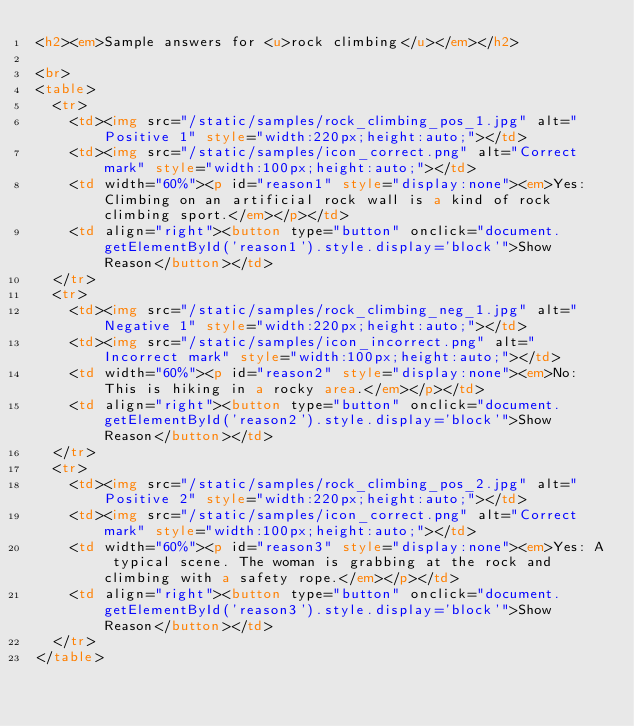Convert code to text. <code><loc_0><loc_0><loc_500><loc_500><_HTML_><h2><em>Sample answers for <u>rock climbing</u></em></h2>

<br>
<table>
	<tr>
		<td><img src="/static/samples/rock_climbing_pos_1.jpg" alt="Positive 1" style="width:220px;height:auto;"></td>
		<td><img src="/static/samples/icon_correct.png" alt="Correct mark" style="width:100px;height:auto;"></td>
		<td width="60%"><p id="reason1" style="display:none"><em>Yes: Climbing on an artificial rock wall is a kind of rock climbing sport.</em></p></td>
		<td align="right"><button type="button" onclick="document.getElementById('reason1').style.display='block'">Show Reason</button></td>
	</tr>
	<tr>
		<td><img src="/static/samples/rock_climbing_neg_1.jpg" alt="Negative 1" style="width:220px;height:auto;"></td>
		<td><img src="/static/samples/icon_incorrect.png" alt="Incorrect mark" style="width:100px;height:auto;"></td>
		<td width="60%"><p id="reason2" style="display:none"><em>No: This is hiking in a rocky area.</em></p></td>
		<td align="right"><button type="button" onclick="document.getElementById('reason2').style.display='block'">Show Reason</button></td>
	</tr>
	<tr>
		<td><img src="/static/samples/rock_climbing_pos_2.jpg" alt="Positive 2" style="width:220px;height:auto;"></td>
		<td><img src="/static/samples/icon_correct.png" alt="Correct mark" style="width:100px;height:auto;"></td>
		<td width="60%"><p id="reason3" style="display:none"><em>Yes: A typical scene. The woman is grabbing at the rock and climbing with a safety rope.</em></p></td>
		<td align="right"><button type="button" onclick="document.getElementById('reason3').style.display='block'">Show Reason</button></td>
	</tr>
</table></code> 